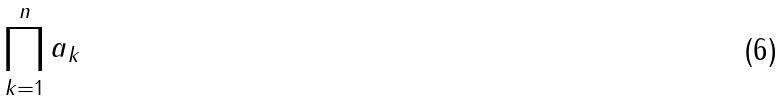<formula> <loc_0><loc_0><loc_500><loc_500>\prod _ { k = 1 } ^ { n } a _ { k }</formula> 